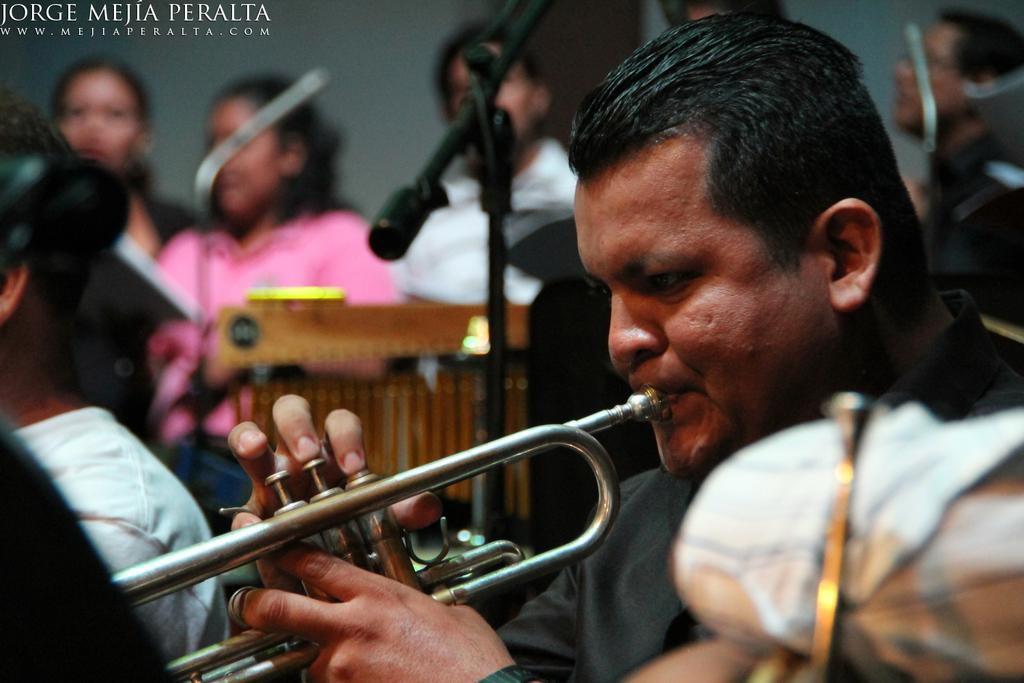What is the main subject of the image? There is a person playing a trumpet in the image. Where is the person playing the trumpet located in the image? The person is in the center of the image. Are there any other people present in the image? Yes, there are other people in the image. What objects can be seen in the image that are related to sound amplification? There are microphones in the image. How many cars can be seen in the image? There are no cars present in the image. What is the girl doing in the image? There is no girl present in the image. 